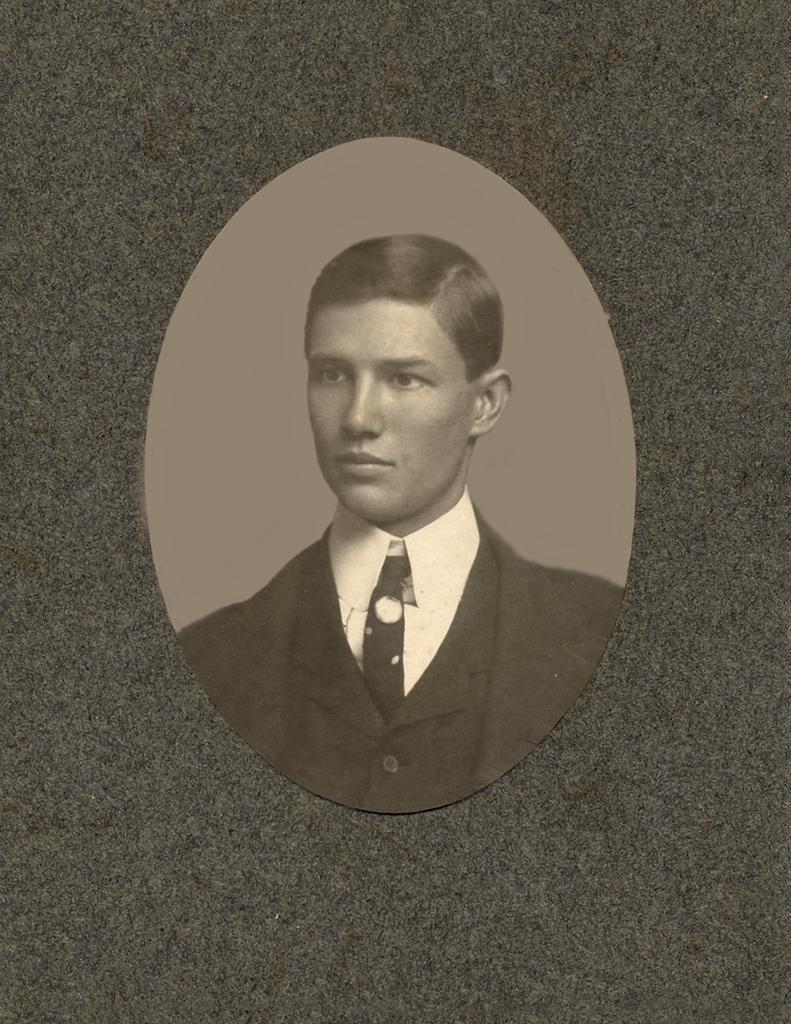What is the color scheme of the image? The image is black and white. Can you describe the main subject in the image? There is a person in the image. What can be observed about the person's attire? The person is wearing clothes. Is there a house with a farm and a collar visible in the image? No, there is no house, farm, or collar present in the image. The image is black and white and features a person wearing clothes. 